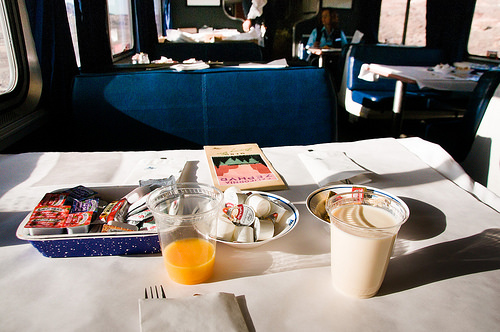<image>
Can you confirm if the cup is behind the plate? No. The cup is not behind the plate. From this viewpoint, the cup appears to be positioned elsewhere in the scene. Where is the drink in relation to the fork? Is it next to the fork? Yes. The drink is positioned adjacent to the fork, located nearby in the same general area. 